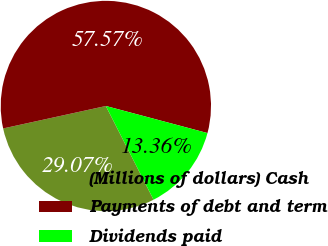<chart> <loc_0><loc_0><loc_500><loc_500><pie_chart><fcel>(Millions of dollars) Cash<fcel>Payments of debt and term<fcel>Dividends paid<nl><fcel>29.07%<fcel>57.57%<fcel>13.36%<nl></chart> 